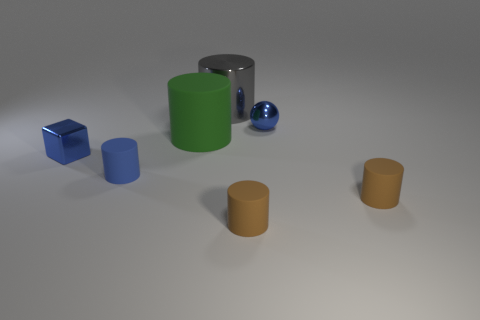How many objects are both in front of the big metal cylinder and right of the blue cylinder?
Provide a succinct answer. 4. There is a small rubber cylinder that is to the left of the gray thing; is it the same color as the ball?
Make the answer very short. Yes. Does the blue sphere have the same size as the green matte thing?
Provide a succinct answer. No. Is the color of the tiny shiny block the same as the tiny shiny object to the right of the small blue rubber cylinder?
Your answer should be very brief. Yes. There is a blue object that is the same material as the block; what is its shape?
Make the answer very short. Sphere. There is another large cylinder that is made of the same material as the blue cylinder; what is its color?
Offer a terse response. Green. What number of things are small balls or tiny blue things in front of the tiny ball?
Ensure brevity in your answer.  3. What is the small blue cylinder in front of the big green cylinder made of?
Give a very brief answer. Rubber. What shape is the green object that is the same size as the gray metal cylinder?
Give a very brief answer. Cylinder. Are there any big green rubber objects that have the same shape as the tiny blue rubber object?
Your answer should be compact. Yes. 